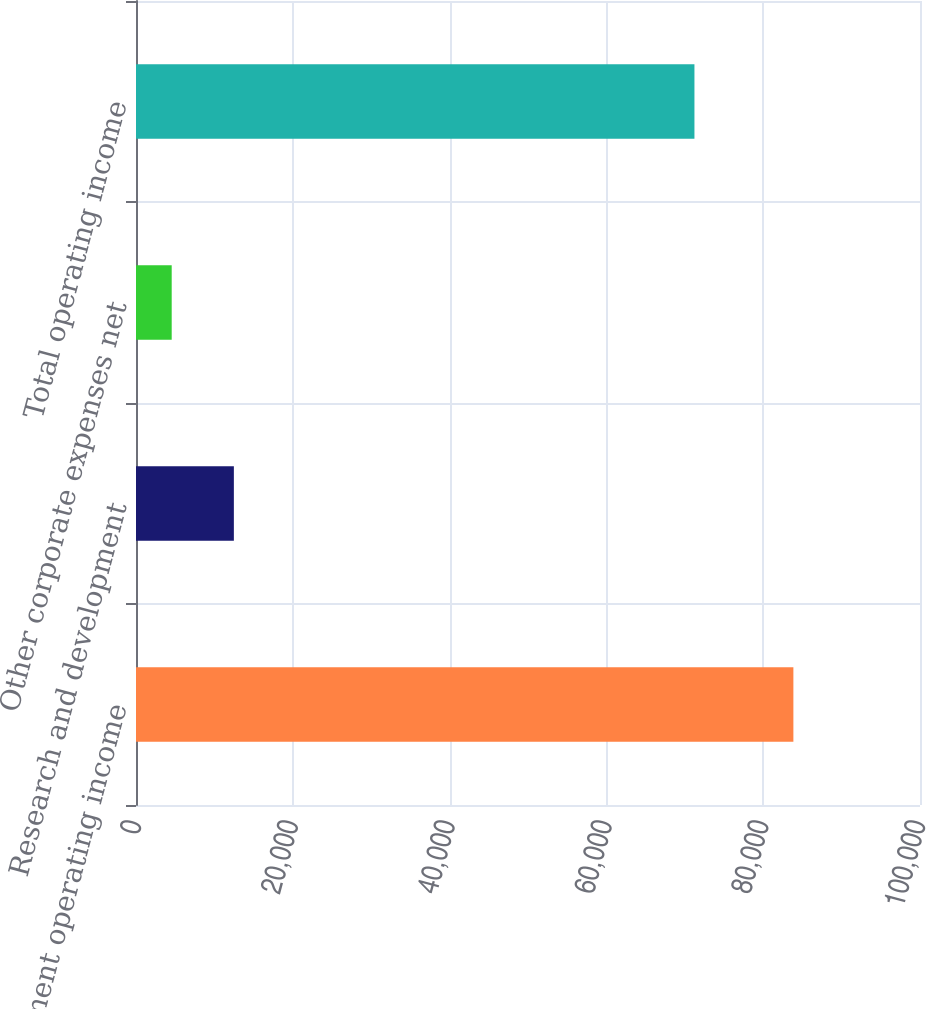Convert chart. <chart><loc_0><loc_0><loc_500><loc_500><bar_chart><fcel>Segment operating income<fcel>Research and development<fcel>Other corporate expenses net<fcel>Total operating income<nl><fcel>83850<fcel>12482.7<fcel>4553<fcel>71230<nl></chart> 